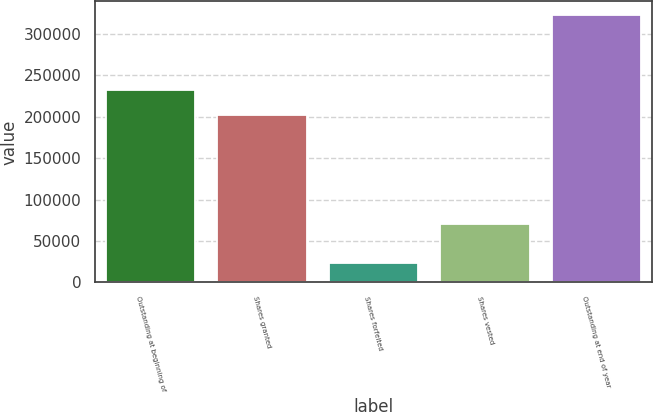Convert chart to OTSL. <chart><loc_0><loc_0><loc_500><loc_500><bar_chart><fcel>Outstanding at beginning of<fcel>Shares granted<fcel>Shares forfeited<fcel>Shares vested<fcel>Outstanding at end of year<nl><fcel>232308<fcel>202411<fcel>23953<fcel>70667<fcel>322925<nl></chart> 